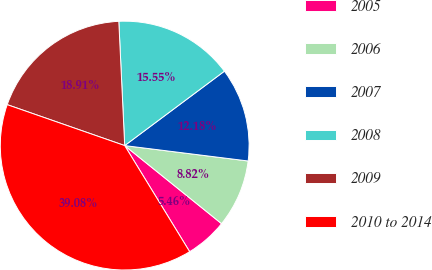Convert chart. <chart><loc_0><loc_0><loc_500><loc_500><pie_chart><fcel>2005<fcel>2006<fcel>2007<fcel>2008<fcel>2009<fcel>2010 to 2014<nl><fcel>5.46%<fcel>8.82%<fcel>12.18%<fcel>15.55%<fcel>18.91%<fcel>39.08%<nl></chart> 